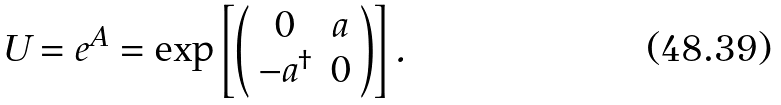Convert formula to latex. <formula><loc_0><loc_0><loc_500><loc_500>U = e ^ { A } = \exp \left [ \left ( \begin{array} { c c } 0 & a \\ - a ^ { \dag } & 0 \end{array} \right ) \right ] .</formula> 